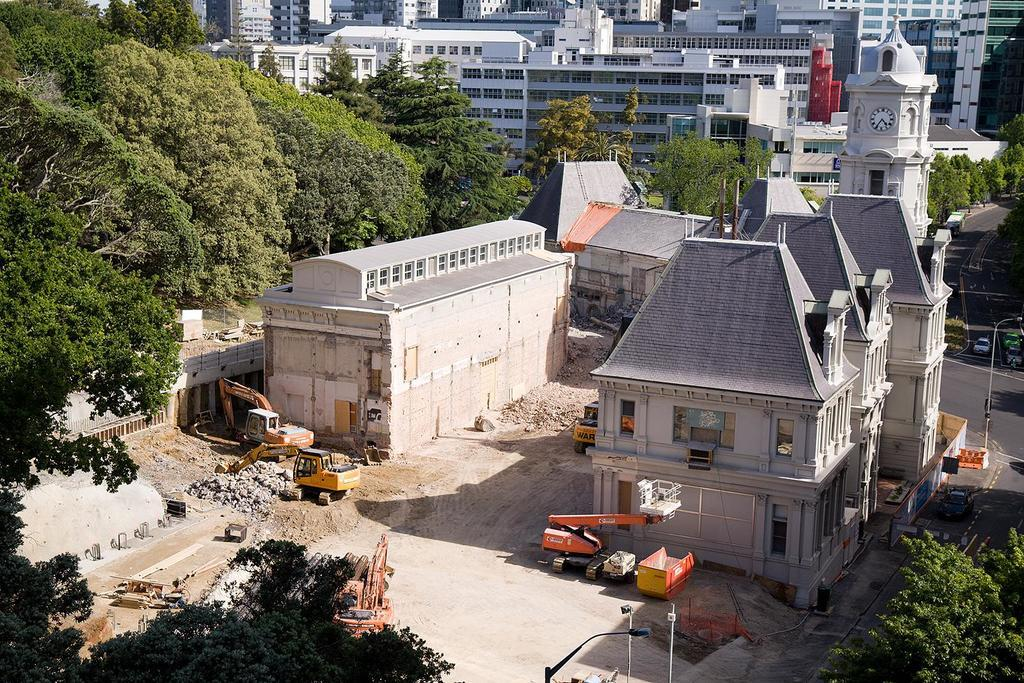What type of natural elements can be seen in the image? There are trees in the image. What type of man-made structures are visible in the image? There are buildings in the image. What type of objects are used for supporting electrical wires or street signs? There are poles in the image. What type of vehicles can be seen in the image? There are vehicles in the image. Where are the cars located in the image? The cars are on the right side of the image. What type of butter is being spread on the trees in the image? There is no butter present in the image; it features trees, vehicles, buildings, and poles. How does the light affect the visibility of the image? The provided facts do not mention any lighting conditions, so it is impossible to determine how light affects the visibility of the image. 